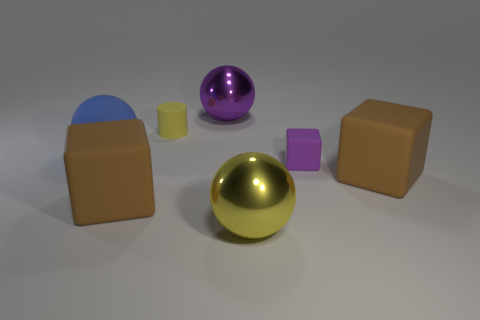If this image was part of a story, what role could these objects play? In a story, these objects could be mystical artifacts with unique powers or futuristic devices central to the plot. Their distinct shapes and shimmering surfaces might suggest they each hold a different kind of importance or ability. 